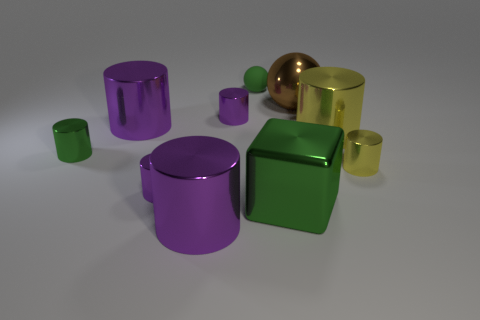Is there anything else that has the same shape as the big green metal thing?
Your response must be concise. No. Is the number of metallic cylinders less than the number of purple cylinders?
Provide a short and direct response. No. Are there any big brown spheres made of the same material as the green cylinder?
Offer a very short reply. Yes. There is a large brown thing; does it have the same shape as the purple shiny thing that is in front of the big green shiny thing?
Give a very brief answer. No. There is a big green object; are there any brown metal objects to the left of it?
Ensure brevity in your answer.  No. How many large green metal objects are the same shape as the rubber object?
Make the answer very short. 0. Are the brown thing and the small yellow cylinder that is in front of the brown object made of the same material?
Make the answer very short. Yes. What number of big yellow metallic things are there?
Keep it short and to the point. 1. How big is the yellow metallic cylinder that is in front of the green metallic cylinder?
Make the answer very short. Small. How many green objects have the same size as the green ball?
Your response must be concise. 1. 